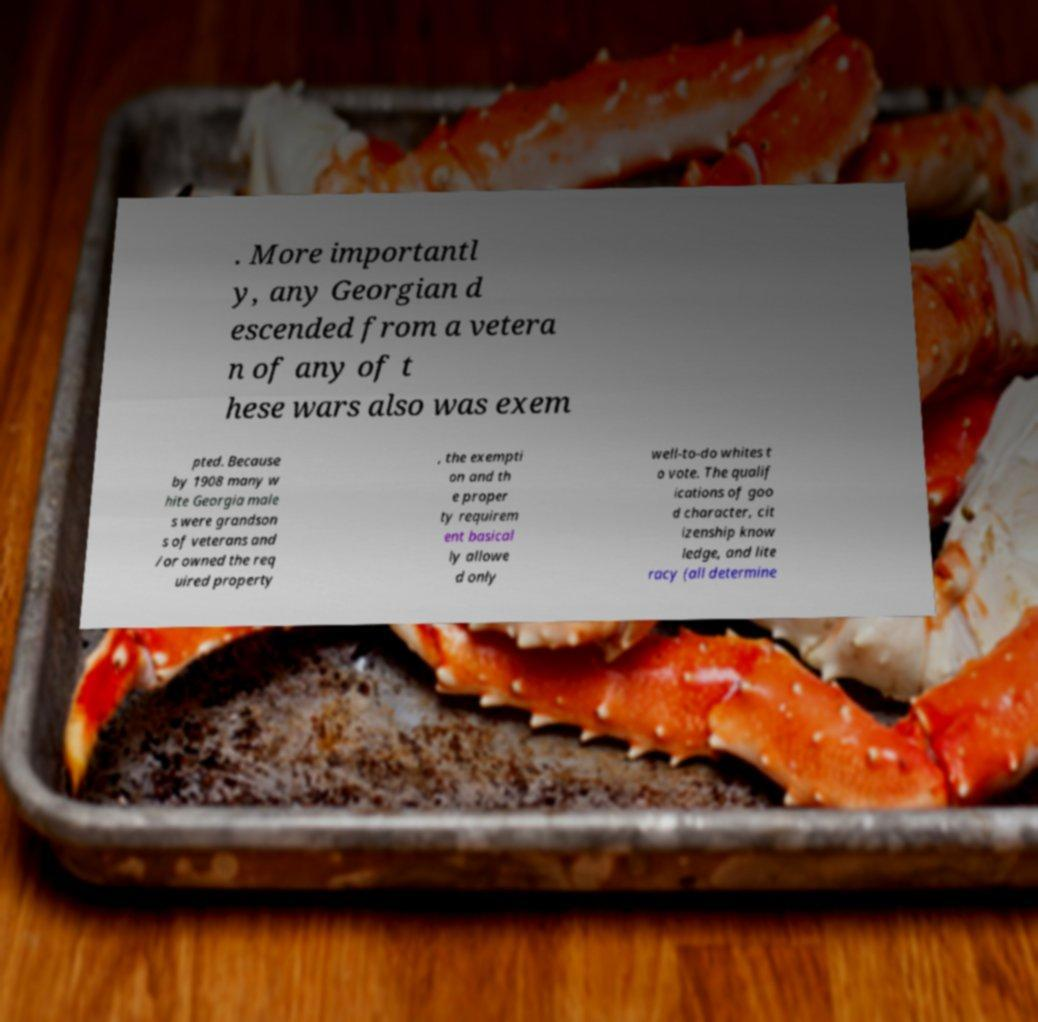For documentation purposes, I need the text within this image transcribed. Could you provide that? . More importantl y, any Georgian d escended from a vetera n of any of t hese wars also was exem pted. Because by 1908 many w hite Georgia male s were grandson s of veterans and /or owned the req uired property , the exempti on and th e proper ty requirem ent basical ly allowe d only well-to-do whites t o vote. The qualif ications of goo d character, cit izenship know ledge, and lite racy (all determine 